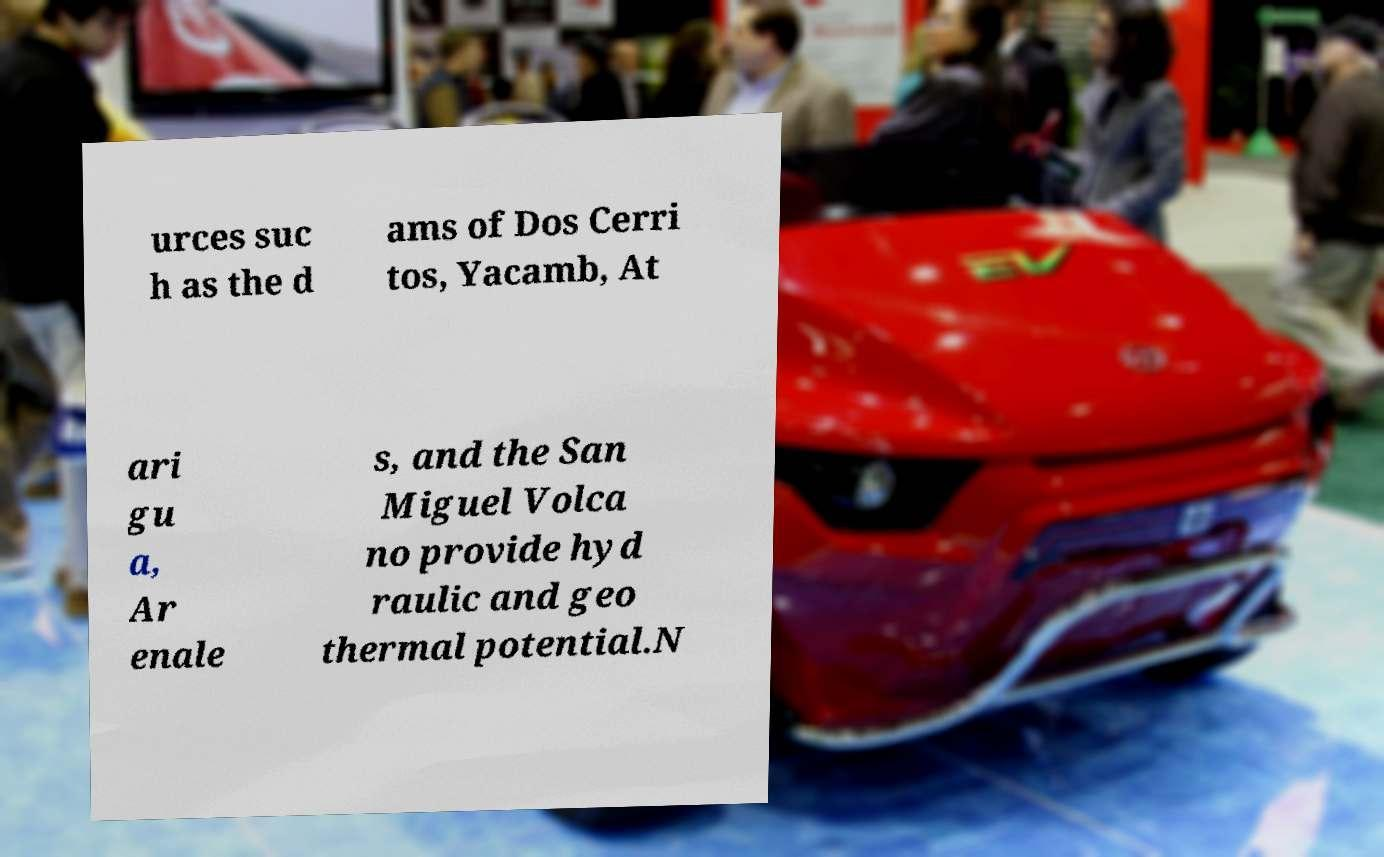Please identify and transcribe the text found in this image. urces suc h as the d ams of Dos Cerri tos, Yacamb, At ari gu a, Ar enale s, and the San Miguel Volca no provide hyd raulic and geo thermal potential.N 